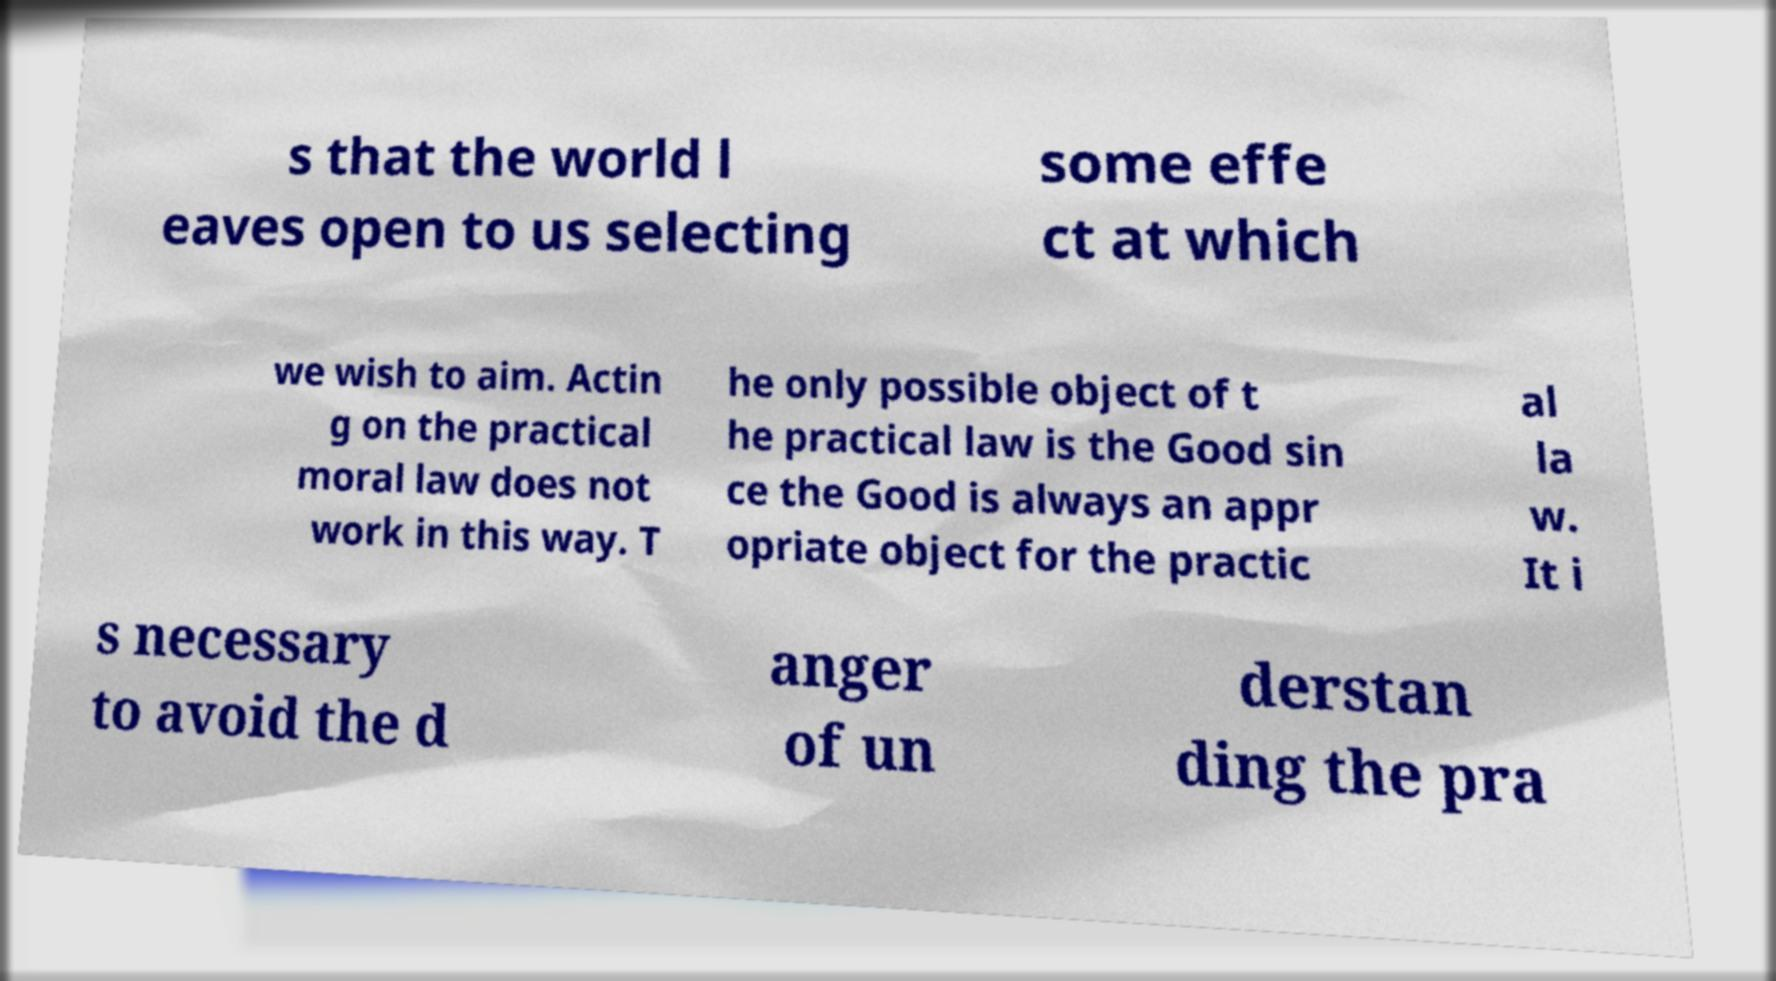What messages or text are displayed in this image? I need them in a readable, typed format. s that the world l eaves open to us selecting some effe ct at which we wish to aim. Actin g on the practical moral law does not work in this way. T he only possible object of t he practical law is the Good sin ce the Good is always an appr opriate object for the practic al la w. It i s necessary to avoid the d anger of un derstan ding the pra 